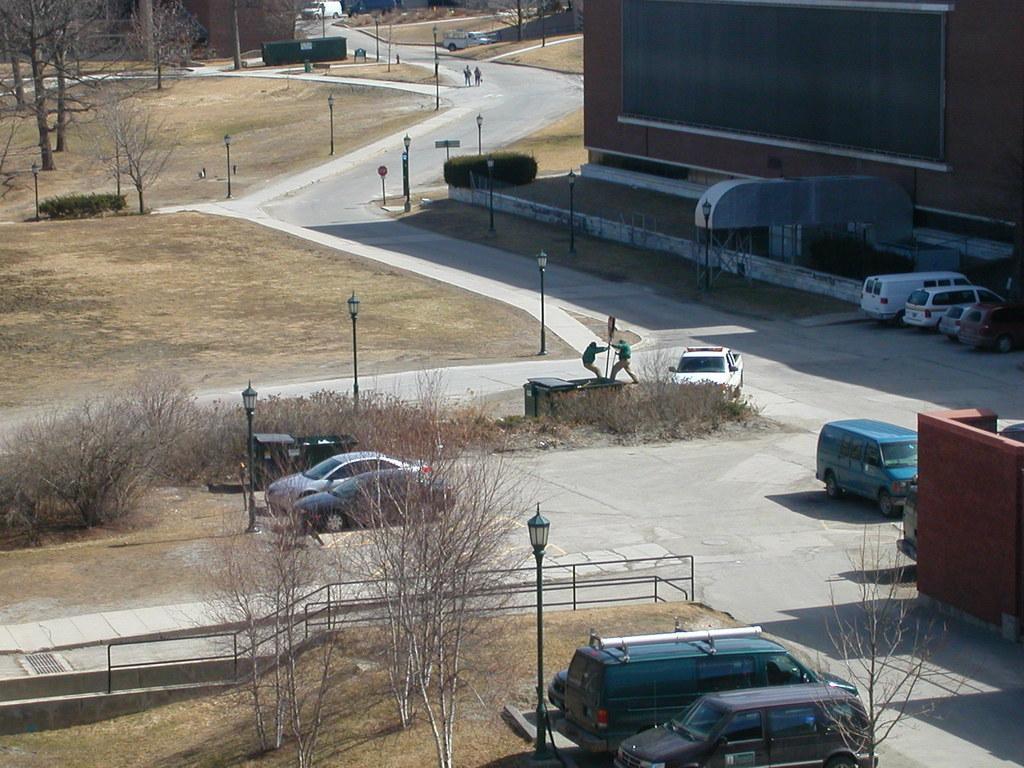Could you give a brief overview of what you see in this image? In this picture we can see there are some vehicles on the path and on the left side of the vehicles there are trees and on the right side of the vehicles there are buildings. 